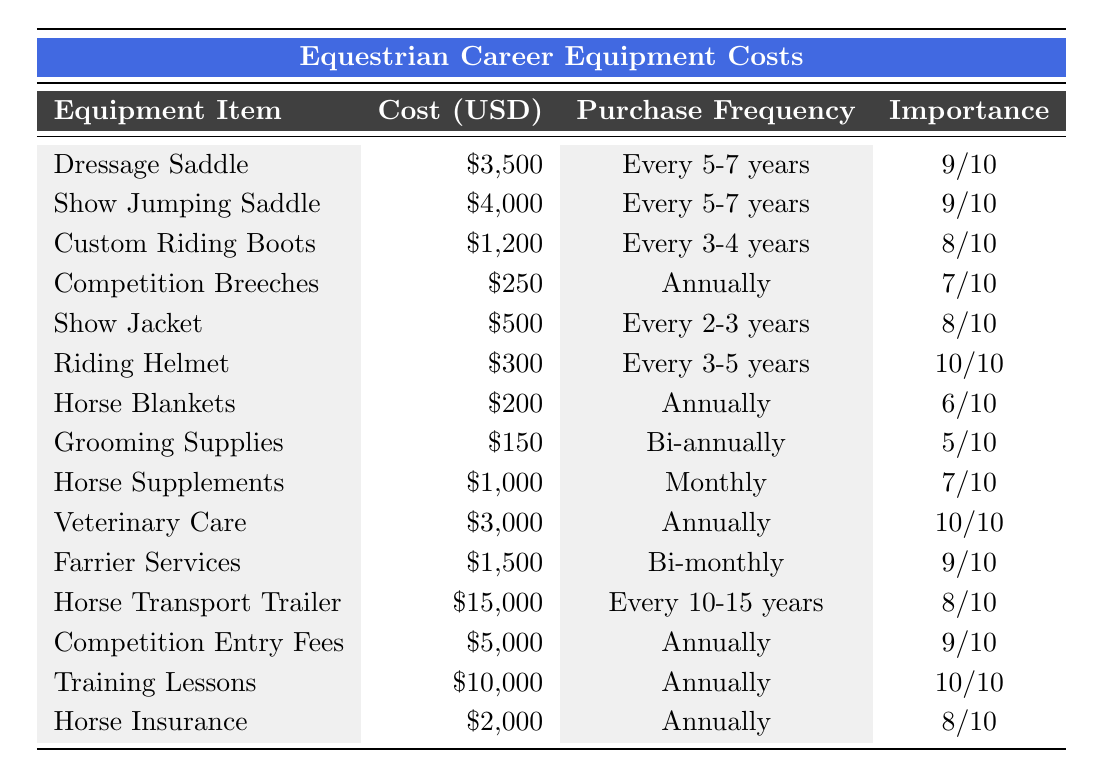What is the most expensive equipment item listed in the table? The table shows the cost of each equipment item. The Horse Transport Trailer costs $15,000, which is higher than all other items.
Answer: $15,000 How often do you need to purchase a Riding Helmet? The table states that a Riding Helmet is purchased every 3-5 years, which indicates that it has a long useful life.
Answer: Every 3-5 years What is the total cost of Veterinary Care and Training Lessons annually? The annual cost for Veterinary Care is $3,000 and for Training Lessons, it is $10,000. Therefore, the total is $3,000 + $10,000 = $13,000.
Answer: $13,000 Is a Show Jumping Saddle considered more important than a Custom Riding Boot? The importance rating for the Show Jumping Saddle is 9, while for Custom Riding Boots it is 8, indicating that the Show Jumping Saddle is more important.
Answer: Yes What is the average importance rating of the items requiring annual purchase frequency? The items requiring annual purchase include: Competition Breeches (7), Horse Blankets (6), Horse Supplements (7), Veterinary Care (10), Competition Entry Fees (9), Training Lessons (10), and Horse Insurance (8). Adding them gives 7 + 6 + 7 + 10 + 9 + 10 + 8 = 57. Dividing by the number of items (7) gives an average of 57/7 ≈ 8.14.
Answer: Approximately 8.14 How many equipment items have a cost below $500? Reviewing the table, the items below $500 are Competition Breeches ($250), Show Jacket ($500), Riding Helmet ($300), and Grooming Supplies ($150), totaling 3 items (Grooming Supplies is below $500).
Answer: 3 If you purchase Horse Supplements monthly, how much would that amount to in a year? Since Horse Supplements cost $1,000 per month, the total for a year would be $1,000 multiplied by 12 months, resulting in $12,000.
Answer: $12,000 What is the total cost of all items that are rated 9 in importance? The items rated 9 in importance are Dressage Saddle ($3,500), Show Jumping Saddle ($4,000), Farrier Services ($1,500), Competition Entry Fees ($5,000), and Training Lessons ($10,000). Summing these gives $3,500 + $4,000 + $1,500 + $5,000 + $10,000 = $24,000.
Answer: $24,000 Is it true that all items with a purchase frequency of 'Annually' have an importance rating of at least 6? The items purchased annually are Competition Breeches (7), Horse Blankets (6), Veterinary Care (10), Competition Entry Fees (9), Training Lessons (10), and Horse Insurance (8). All have importance ratings of 6 or higher, making the statement true.
Answer: Yes 